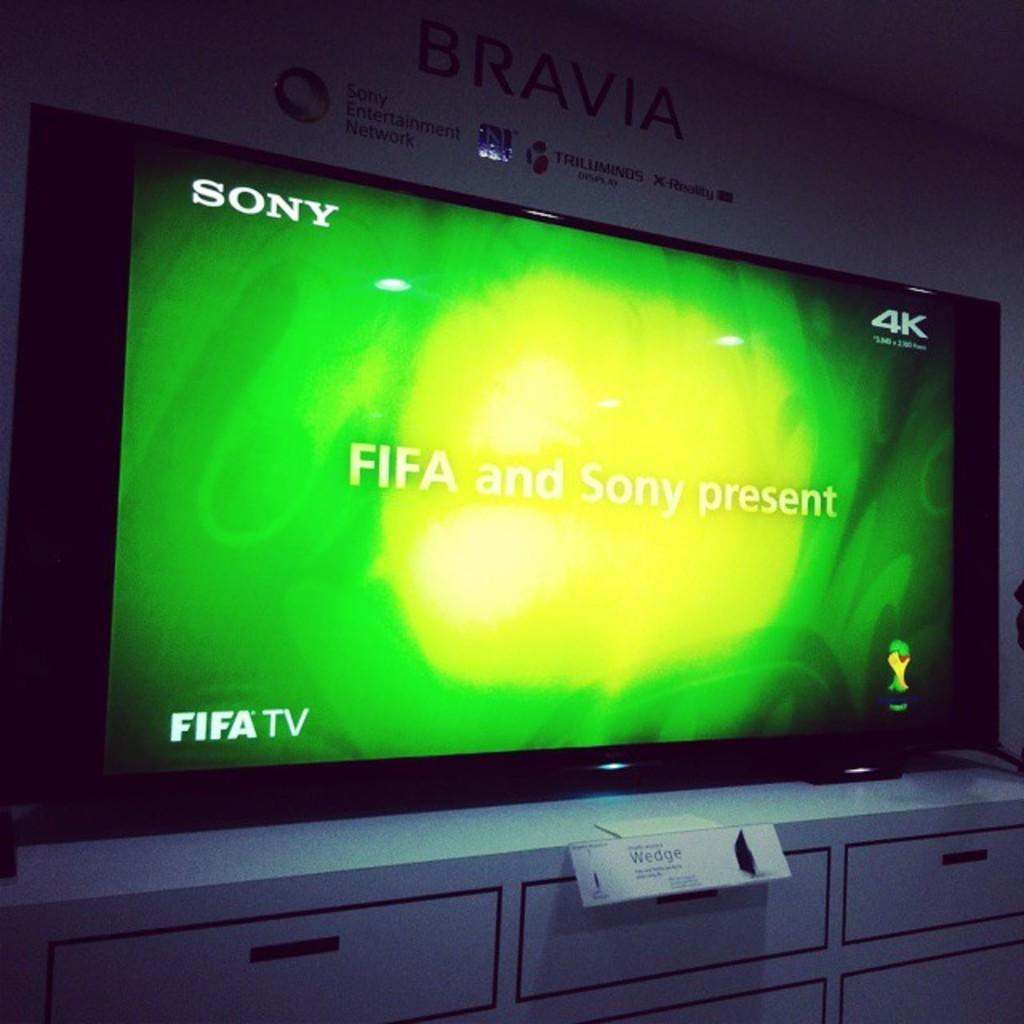Provide a one-sentence caption for the provided image. A 4k Bravia TV on top of a white tv stand. 